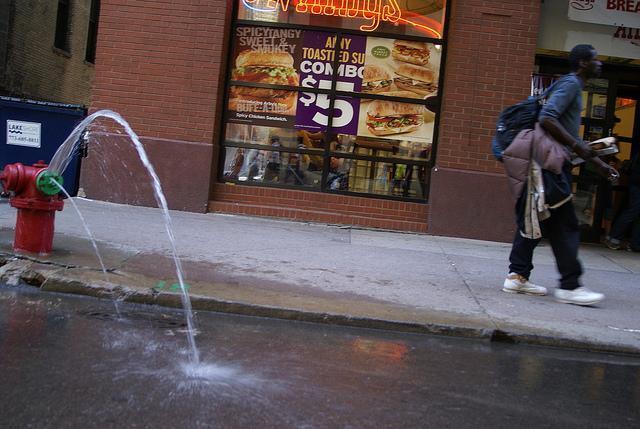How many people are there?
Give a very brief answer. 1. 